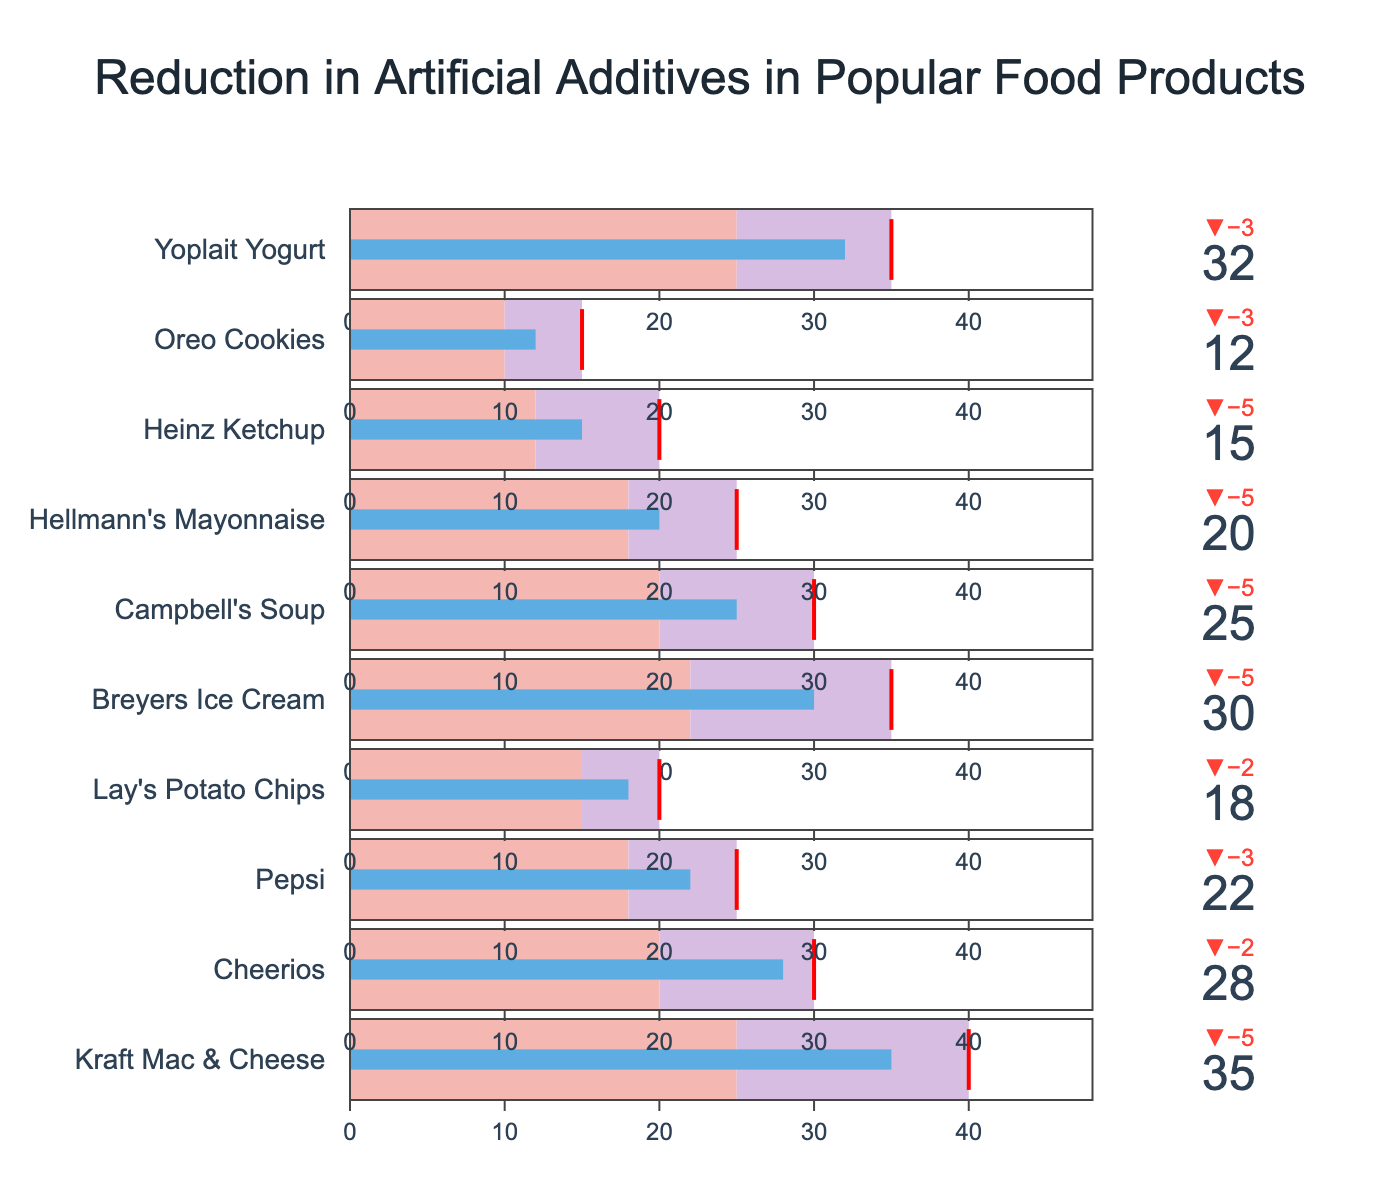What's the title of the figure? The title is generally placed at the top center of the chart. In this figure, it's easily identifiable.
Answer: "Reduction in Artificial Additives in Popular Food Products" How many product categories are displayed in the figure? By looking at the number of bullet traces in the chart, we can count the different food product categories.
Answer: 10 Which product achieved the highest reduction in artificial additives? Examine the bullet chart, identify the product with the highest value on the gauge.
Answer: "Kraft Mac & Cheese" How does Kraft Mac & Cheese's reduction in artificial additives compare to its target reduction? Check the value, the target, and the delta indicator associated with Kraft Mac & Cheese.
Answer: 35% reduction vs. 40% target, 5% short Which products have an actual reduction in additives lower than their target reduction? Compare the values and target reduction percentage for each product to check if the actual is less than the target.
Answer: "Kraft Mac & Cheese", "Cheerios", "Pepsi", "Lay's Potato Chips", "Breyers Ice Cream", "Campbell's Soup", "Hellmann's Mayonnaise", "Heinz Ketchup", "Oreo Cookies", "Yoplait Yogurt" What is the deviation of Pepsi's actual reduction from the industry average? Determine the actual reduction for Pepsi and subtract the industry average given for Pepsi.
Answer: 22% - 18% = 4% Which product has the smallest reduction in artificial additives? Identify the product on the bullet chart with the lowest value.
Answer: "Oreo Cookies" How many products met or exceeded their target reduction? Cross-check each product's actual reduction against its target reduction to count those that met or exceeded the target.
Answer: 0 (None met or exceeded their target) What is the average target reduction across all products? Sum the target reductions for all products and divide by the number of products.
Answer: (40 + 30 + 25 + 20 + 35 + 30 + 25 + 20 + 15 + 35) / 10 = 27.5% 